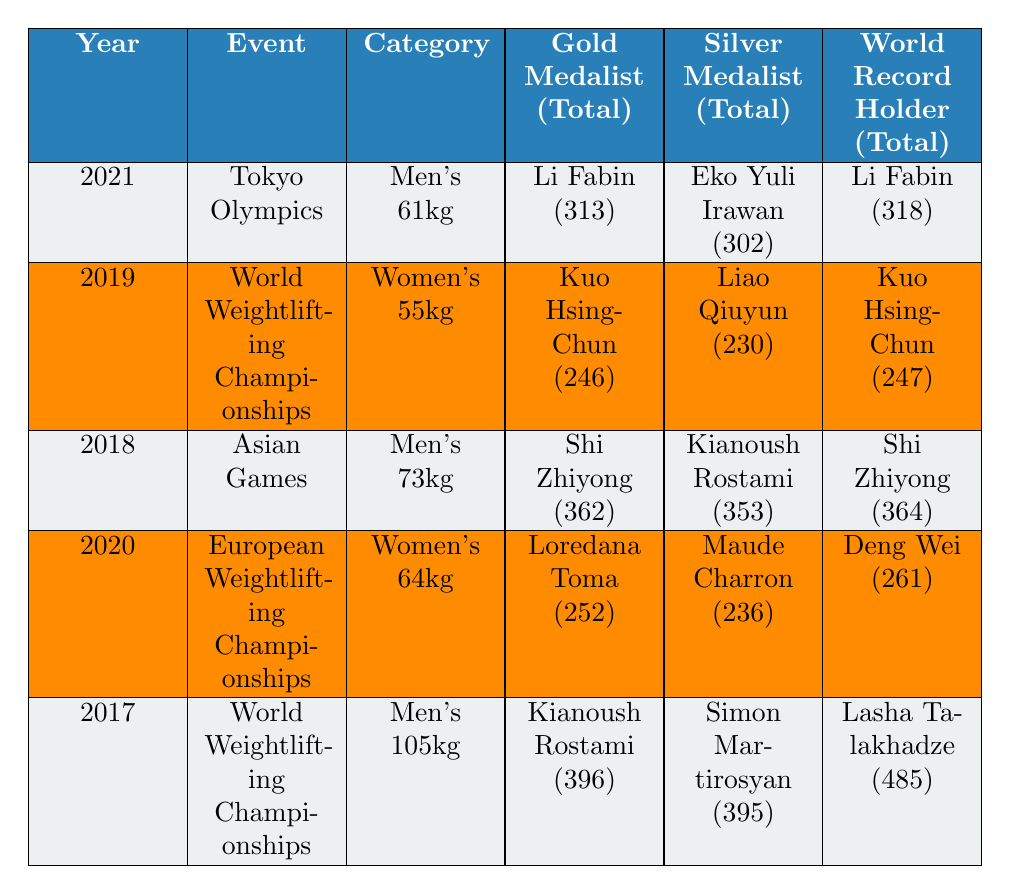What year was the Tokyo Olympics held? The table indicates that the event named "Tokyo Olympics" occurred in the year 2021.
Answer: 2021 Who won the gold medal in the Women's 55kg category? According to the table for the World Weightlifting Championships in 2019, Kuo Hsing-Chun won the gold medal in the Women's 55kg category.
Answer: Kuo Hsing-Chun What was the total weight lifted by the bronze medalist in the Men's 105kg category in 2017? The table shows that the bronze medalist, Tian Tao, lifted a total of 394kg in the Men's 105kg category during the 2017 World Weightlifting Championships.
Answer: 394 Who holds the world record for the Men's 73kg category? The world record holder for the Men's 73kg category is Shi Zhiyong, as noted in the Asian Games of 2018.
Answer: Shi Zhiyong What is the difference in the total weight lifted between the gold medalists of the Men's 61kg and Men's 105kg categories? The gold total for Li Fabin in the Men's 61kg is 313kg, and for Kianoush Rostami in the Men's 105kg, it is 396kg. The difference is 396 - 313 = 83kg.
Answer: 83 Which event had the highest total weight lifted by a gold medalist? Comparing the gold totals: Li Fabin (313kg in 2021), Kuo Hsing-Chun (246kg in 2019), Shi Zhiyong (362kg in 2018), Loredana Toma (252kg in 2020), and Kianoush Rostami (396kg in 2017), Kianoush lifted 396kg, which is the highest.
Answer: 396kg If we look at the Women's categories in the past five years, which event had the lowest gold medal total? The Women's categories are from the 2019 and 2020 events: Kuo Hsing-Chun lifted 246kg and Loredana Toma lifted 252kg. Therefore, 246kg is the lowest.
Answer: 246kg Was there any world record broken at the Tokyo Olympics? The table shows that Li Fabin, the gold medalist, holds the world record for the Men's 61kg category with a total of 318kg, indicating a record was achieved at this event.
Answer: Yes What is the average total weight lifted by the silver medalist across all events in the table? Summing the silver totals gives: 302 + 230 + 353 + 236 + 395 = 1,516kg. With 5 events, the average is 1,516 / 5 = 303.2kg.
Answer: 303.2kg In which event did the world record occur that was higher than the total lifted by the gold medalist? For the Tokyo Olympics, Li Fabin's total was 313kg, and he matched his world record of 318kg. In the Men's 105kg of 2017, Lasha Talakhadze holds a record of 485kg, arguably higher than Rostami's 396kg; hence, both events had records higher than gold totals.
Answer: Tokyo Olympics and Men's 105kg 2017 